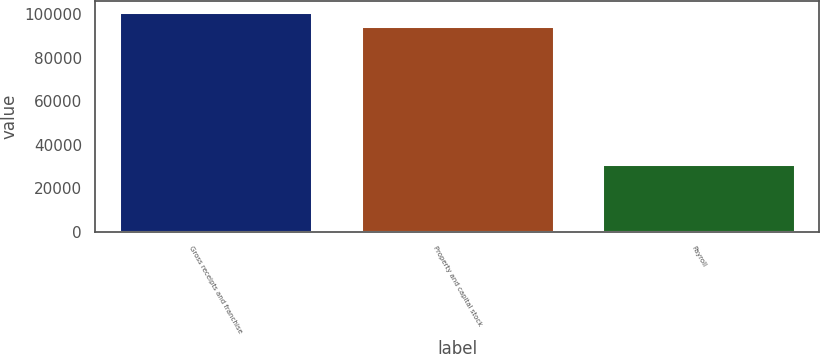Convert chart. <chart><loc_0><loc_0><loc_500><loc_500><bar_chart><fcel>Gross receipts and franchise<fcel>Property and capital stock<fcel>Payroll<nl><fcel>100915<fcel>94448<fcel>31375<nl></chart> 